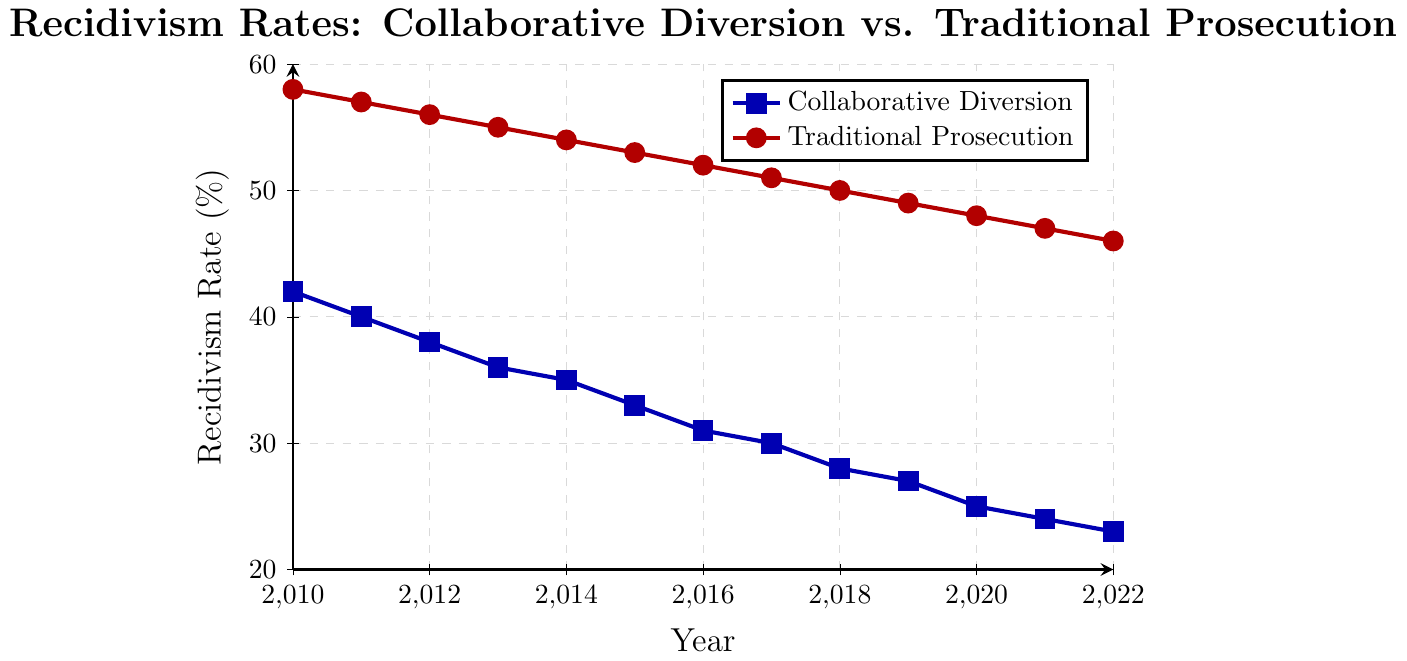What's the trend of recidivism rates for Collaborative Diversion from 2010 to 2022? The recidivism rates for Collaborative Diversion show a consistent downward trend from 42% in 2010 to 23% in 2022. This indicates an overall decrease in recidivism for offenders processed through collaborative diversion programs.
Answer: Downward trend How do the recidivism rates for Traditional Prosecution in 2010 compare to Collaborative Diversion in the same year? In 2010, the recidivism rate for Traditional Prosecution was 58%, while for Collaborative Diversion, it was 42%. Traditional Prosecution had a higher recidivism rate compared to Collaborative Diversion by 16 percentage points.
Answer: Traditional Prosecution is higher What's the average recidivism rate for Collaborative Diversion from 2010 to 2015? First, sum the recidivism rates from 2010 to 2015 for Collaborative Diversion: 42 + 40 + 38 + 36 + 35 + 33 = 224. There are 6 years, so the average is 224 / 6 = 37.33%.
Answer: 37.33% By how much did the recidivism rate for Traditional Prosecution decrease from 2010 to 2022? The recidivism rate for Traditional Prosecution was 58% in 2010 and 46% in 2022. The decrease is 58 - 46 = 12 percentage points.
Answer: 12 percentage points Which year shows the smallest difference in recidivism rates between Collaborative Diversion and Traditional Prosecution? To find this, calculate the difference for each year and determine the smallest. Differences: 2010: 16, 2011: 17, 2012: 18, 2013: 19, 2014: 19, 2015: 20, 2016: 21, 2017: 21, 2018: 22, 2019: 22, 2020: 23, 2021: 23, 2022: 23. The smallest difference is 16 in 2010.
Answer: 2010 How do the recidivism rates for Collaborative Diversion and Traditional Prosecution compare in 2020? For 2020, the recidivism rate for Collaborative Diversion is 25%, and for Traditional Prosecution, it is 48%. Traditional Prosecution has a higher rate by 23 percentage points.
Answer: Traditional Prosecution is higher What is the average annual rate of decrease in recidivism for Collaborative Diversion from 2010 to 2022? Calculate the decrease over 12 years: Initial rate is 42% in 2010, final rate is 23% in 2022. The total decrease is 42 - 23 = 19%. The average annual rate of decrease is 19% / 12 = 1.58% per year.
Answer: 1.58% per year Which line in the plot corresponds to Collaborative Diversion, and which corresponds to Traditional Prosecution? The line for Collaborative Diversion is blue with square markers, while the line for Traditional Prosecution is red with circular markers.
Answer: Blue line for Collaborative Diversion; Red line for Traditional Prosecution 